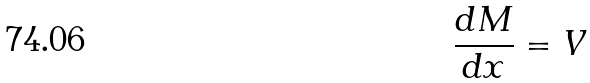Convert formula to latex. <formula><loc_0><loc_0><loc_500><loc_500>\frac { d M } { d x } = V</formula> 